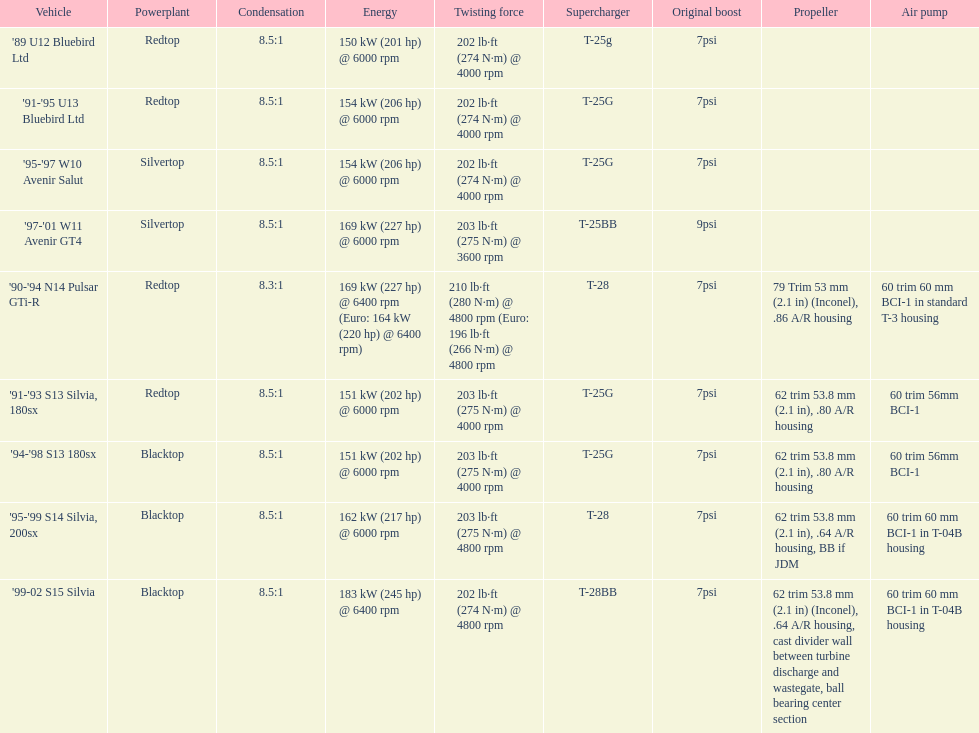Which car is the only one with more than 230 hp? '99-02 S15 Silvia. 